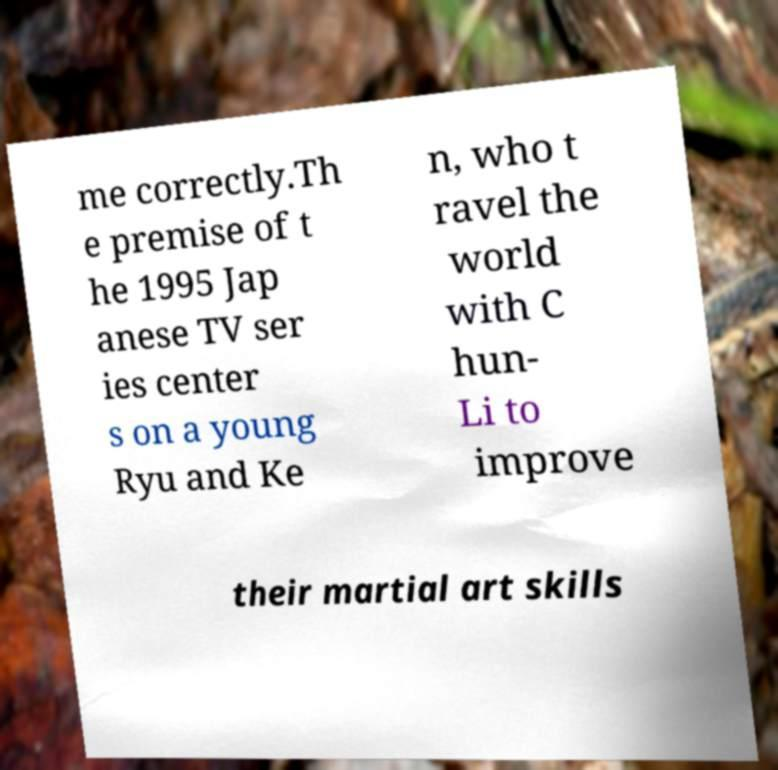Please read and relay the text visible in this image. What does it say? me correctly.Th e premise of t he 1995 Jap anese TV ser ies center s on a young Ryu and Ke n, who t ravel the world with C hun- Li to improve their martial art skills 